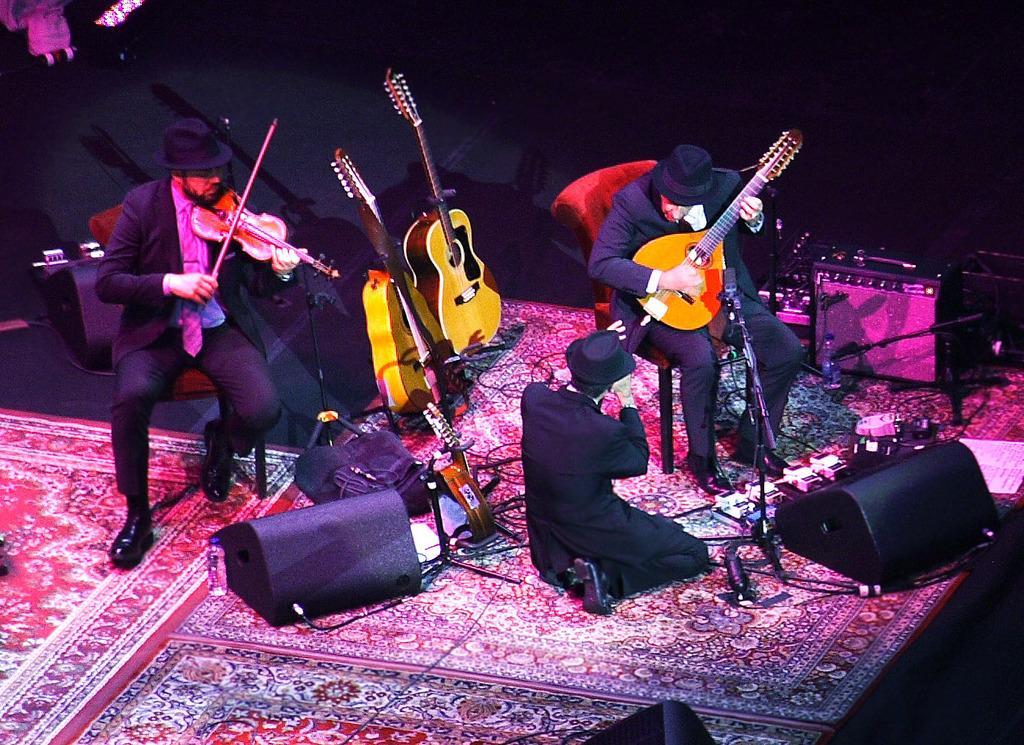How would you summarize this image in a sentence or two? In this image I see 3 men, in which both of them are sitting on the chairs and holding a musical instrument. I can also see that there are 2 guitars over here and few things on the floor. 